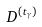Convert formula to latex. <formula><loc_0><loc_0><loc_500><loc_500>D ^ { ( t _ { \gamma } ) }</formula> 